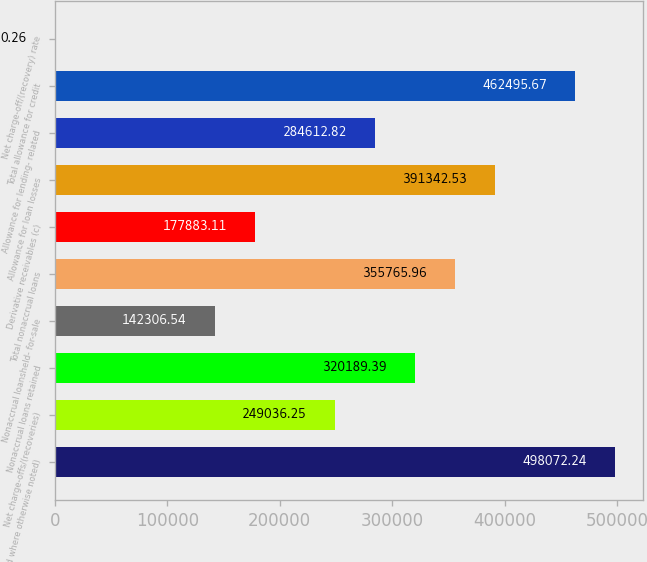Convert chart to OTSL. <chart><loc_0><loc_0><loc_500><loc_500><bar_chart><fcel>and where otherwise noted)<fcel>Net charge-offs/(recoveries)<fcel>Nonaccrual loans retained<fcel>Nonaccrual loansheld- for-sale<fcel>Total nonaccrual loans<fcel>Derivative receivables (c)<fcel>Allowance for loan losses<fcel>Allowance for lending- related<fcel>Total allowance for credit<fcel>Net charge-off/(recovery) rate<nl><fcel>498072<fcel>249036<fcel>320189<fcel>142307<fcel>355766<fcel>177883<fcel>391343<fcel>284613<fcel>462496<fcel>0.26<nl></chart> 